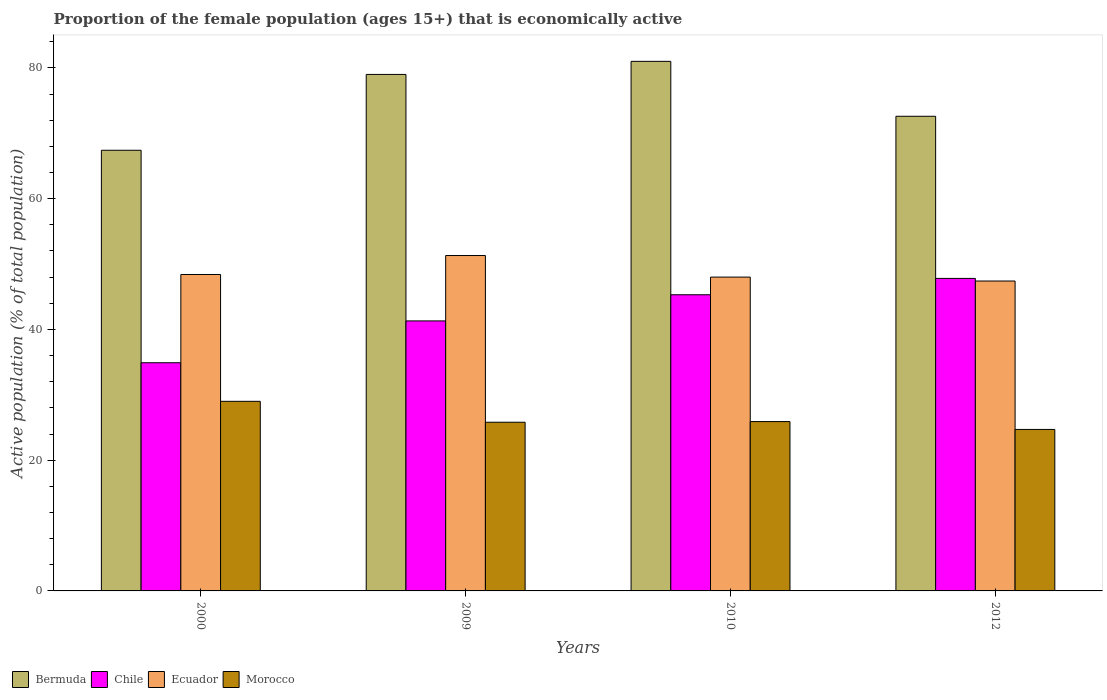How many groups of bars are there?
Offer a very short reply. 4. How many bars are there on the 3rd tick from the left?
Provide a short and direct response. 4. What is the label of the 1st group of bars from the left?
Offer a very short reply. 2000. In how many cases, is the number of bars for a given year not equal to the number of legend labels?
Make the answer very short. 0. What is the proportion of the female population that is economically active in Bermuda in 2009?
Your response must be concise. 79. Across all years, what is the maximum proportion of the female population that is economically active in Bermuda?
Ensure brevity in your answer.  81. Across all years, what is the minimum proportion of the female population that is economically active in Chile?
Offer a terse response. 34.9. In which year was the proportion of the female population that is economically active in Morocco maximum?
Ensure brevity in your answer.  2000. What is the total proportion of the female population that is economically active in Bermuda in the graph?
Keep it short and to the point. 300. What is the difference between the proportion of the female population that is economically active in Ecuador in 2009 and that in 2012?
Make the answer very short. 3.9. What is the difference between the proportion of the female population that is economically active in Chile in 2000 and the proportion of the female population that is economically active in Bermuda in 2012?
Your response must be concise. -37.7. What is the average proportion of the female population that is economically active in Morocco per year?
Your answer should be compact. 26.35. In the year 2000, what is the difference between the proportion of the female population that is economically active in Morocco and proportion of the female population that is economically active in Chile?
Your answer should be very brief. -5.9. What is the ratio of the proportion of the female population that is economically active in Morocco in 2010 to that in 2012?
Provide a succinct answer. 1.05. Is the difference between the proportion of the female population that is economically active in Morocco in 2010 and 2012 greater than the difference between the proportion of the female population that is economically active in Chile in 2010 and 2012?
Keep it short and to the point. Yes. What is the difference between the highest and the lowest proportion of the female population that is economically active in Bermuda?
Give a very brief answer. 13.6. In how many years, is the proportion of the female population that is economically active in Bermuda greater than the average proportion of the female population that is economically active in Bermuda taken over all years?
Keep it short and to the point. 2. Is the sum of the proportion of the female population that is economically active in Chile in 2000 and 2010 greater than the maximum proportion of the female population that is economically active in Bermuda across all years?
Offer a very short reply. No. Is it the case that in every year, the sum of the proportion of the female population that is economically active in Morocco and proportion of the female population that is economically active in Ecuador is greater than the sum of proportion of the female population that is economically active in Bermuda and proportion of the female population that is economically active in Chile?
Offer a very short reply. No. What does the 4th bar from the left in 2000 represents?
Give a very brief answer. Morocco. Is it the case that in every year, the sum of the proportion of the female population that is economically active in Ecuador and proportion of the female population that is economically active in Bermuda is greater than the proportion of the female population that is economically active in Morocco?
Offer a very short reply. Yes. Are all the bars in the graph horizontal?
Your response must be concise. No. How many years are there in the graph?
Provide a short and direct response. 4. Are the values on the major ticks of Y-axis written in scientific E-notation?
Your response must be concise. No. Where does the legend appear in the graph?
Provide a succinct answer. Bottom left. What is the title of the graph?
Give a very brief answer. Proportion of the female population (ages 15+) that is economically active. Does "Czech Republic" appear as one of the legend labels in the graph?
Your response must be concise. No. What is the label or title of the X-axis?
Make the answer very short. Years. What is the label or title of the Y-axis?
Your response must be concise. Active population (% of total population). What is the Active population (% of total population) in Bermuda in 2000?
Your answer should be compact. 67.4. What is the Active population (% of total population) of Chile in 2000?
Make the answer very short. 34.9. What is the Active population (% of total population) in Ecuador in 2000?
Provide a succinct answer. 48.4. What is the Active population (% of total population) of Bermuda in 2009?
Offer a terse response. 79. What is the Active population (% of total population) in Chile in 2009?
Keep it short and to the point. 41.3. What is the Active population (% of total population) of Ecuador in 2009?
Make the answer very short. 51.3. What is the Active population (% of total population) in Morocco in 2009?
Provide a succinct answer. 25.8. What is the Active population (% of total population) of Chile in 2010?
Ensure brevity in your answer.  45.3. What is the Active population (% of total population) of Morocco in 2010?
Give a very brief answer. 25.9. What is the Active population (% of total population) in Bermuda in 2012?
Provide a short and direct response. 72.6. What is the Active population (% of total population) in Chile in 2012?
Give a very brief answer. 47.8. What is the Active population (% of total population) in Ecuador in 2012?
Your answer should be very brief. 47.4. What is the Active population (% of total population) in Morocco in 2012?
Provide a short and direct response. 24.7. Across all years, what is the maximum Active population (% of total population) of Bermuda?
Keep it short and to the point. 81. Across all years, what is the maximum Active population (% of total population) of Chile?
Your answer should be very brief. 47.8. Across all years, what is the maximum Active population (% of total population) in Ecuador?
Your answer should be compact. 51.3. Across all years, what is the maximum Active population (% of total population) in Morocco?
Keep it short and to the point. 29. Across all years, what is the minimum Active population (% of total population) in Bermuda?
Ensure brevity in your answer.  67.4. Across all years, what is the minimum Active population (% of total population) of Chile?
Offer a very short reply. 34.9. Across all years, what is the minimum Active population (% of total population) of Ecuador?
Offer a very short reply. 47.4. Across all years, what is the minimum Active population (% of total population) of Morocco?
Your answer should be compact. 24.7. What is the total Active population (% of total population) of Bermuda in the graph?
Ensure brevity in your answer.  300. What is the total Active population (% of total population) of Chile in the graph?
Your response must be concise. 169.3. What is the total Active population (% of total population) of Ecuador in the graph?
Provide a succinct answer. 195.1. What is the total Active population (% of total population) in Morocco in the graph?
Give a very brief answer. 105.4. What is the difference between the Active population (% of total population) in Bermuda in 2000 and that in 2009?
Ensure brevity in your answer.  -11.6. What is the difference between the Active population (% of total population) of Chile in 2000 and that in 2009?
Ensure brevity in your answer.  -6.4. What is the difference between the Active population (% of total population) in Bermuda in 2000 and that in 2010?
Ensure brevity in your answer.  -13.6. What is the difference between the Active population (% of total population) in Chile in 2000 and that in 2010?
Give a very brief answer. -10.4. What is the difference between the Active population (% of total population) in Ecuador in 2000 and that in 2010?
Offer a terse response. 0.4. What is the difference between the Active population (% of total population) in Chile in 2000 and that in 2012?
Provide a short and direct response. -12.9. What is the difference between the Active population (% of total population) of Bermuda in 2009 and that in 2010?
Your answer should be compact. -2. What is the difference between the Active population (% of total population) in Chile in 2009 and that in 2010?
Make the answer very short. -4. What is the difference between the Active population (% of total population) in Ecuador in 2009 and that in 2010?
Provide a short and direct response. 3.3. What is the difference between the Active population (% of total population) of Bermuda in 2009 and that in 2012?
Provide a succinct answer. 6.4. What is the difference between the Active population (% of total population) of Chile in 2010 and that in 2012?
Your answer should be compact. -2.5. What is the difference between the Active population (% of total population) of Ecuador in 2010 and that in 2012?
Keep it short and to the point. 0.6. What is the difference between the Active population (% of total population) in Bermuda in 2000 and the Active population (% of total population) in Chile in 2009?
Ensure brevity in your answer.  26.1. What is the difference between the Active population (% of total population) in Bermuda in 2000 and the Active population (% of total population) in Ecuador in 2009?
Make the answer very short. 16.1. What is the difference between the Active population (% of total population) in Bermuda in 2000 and the Active population (% of total population) in Morocco in 2009?
Your response must be concise. 41.6. What is the difference between the Active population (% of total population) of Chile in 2000 and the Active population (% of total population) of Ecuador in 2009?
Provide a succinct answer. -16.4. What is the difference between the Active population (% of total population) of Ecuador in 2000 and the Active population (% of total population) of Morocco in 2009?
Make the answer very short. 22.6. What is the difference between the Active population (% of total population) of Bermuda in 2000 and the Active population (% of total population) of Chile in 2010?
Your answer should be compact. 22.1. What is the difference between the Active population (% of total population) in Bermuda in 2000 and the Active population (% of total population) in Ecuador in 2010?
Provide a short and direct response. 19.4. What is the difference between the Active population (% of total population) in Bermuda in 2000 and the Active population (% of total population) in Morocco in 2010?
Your answer should be compact. 41.5. What is the difference between the Active population (% of total population) in Chile in 2000 and the Active population (% of total population) in Ecuador in 2010?
Ensure brevity in your answer.  -13.1. What is the difference between the Active population (% of total population) of Ecuador in 2000 and the Active population (% of total population) of Morocco in 2010?
Make the answer very short. 22.5. What is the difference between the Active population (% of total population) in Bermuda in 2000 and the Active population (% of total population) in Chile in 2012?
Your answer should be very brief. 19.6. What is the difference between the Active population (% of total population) in Bermuda in 2000 and the Active population (% of total population) in Morocco in 2012?
Your response must be concise. 42.7. What is the difference between the Active population (% of total population) in Chile in 2000 and the Active population (% of total population) in Ecuador in 2012?
Keep it short and to the point. -12.5. What is the difference between the Active population (% of total population) in Ecuador in 2000 and the Active population (% of total population) in Morocco in 2012?
Provide a succinct answer. 23.7. What is the difference between the Active population (% of total population) in Bermuda in 2009 and the Active population (% of total population) in Chile in 2010?
Your response must be concise. 33.7. What is the difference between the Active population (% of total population) in Bermuda in 2009 and the Active population (% of total population) in Ecuador in 2010?
Keep it short and to the point. 31. What is the difference between the Active population (% of total population) in Bermuda in 2009 and the Active population (% of total population) in Morocco in 2010?
Your answer should be compact. 53.1. What is the difference between the Active population (% of total population) of Chile in 2009 and the Active population (% of total population) of Morocco in 2010?
Keep it short and to the point. 15.4. What is the difference between the Active population (% of total population) in Ecuador in 2009 and the Active population (% of total population) in Morocco in 2010?
Your answer should be very brief. 25.4. What is the difference between the Active population (% of total population) of Bermuda in 2009 and the Active population (% of total population) of Chile in 2012?
Offer a very short reply. 31.2. What is the difference between the Active population (% of total population) in Bermuda in 2009 and the Active population (% of total population) in Ecuador in 2012?
Ensure brevity in your answer.  31.6. What is the difference between the Active population (% of total population) of Bermuda in 2009 and the Active population (% of total population) of Morocco in 2012?
Offer a very short reply. 54.3. What is the difference between the Active population (% of total population) of Chile in 2009 and the Active population (% of total population) of Ecuador in 2012?
Ensure brevity in your answer.  -6.1. What is the difference between the Active population (% of total population) in Ecuador in 2009 and the Active population (% of total population) in Morocco in 2012?
Your response must be concise. 26.6. What is the difference between the Active population (% of total population) in Bermuda in 2010 and the Active population (% of total population) in Chile in 2012?
Keep it short and to the point. 33.2. What is the difference between the Active population (% of total population) in Bermuda in 2010 and the Active population (% of total population) in Ecuador in 2012?
Provide a short and direct response. 33.6. What is the difference between the Active population (% of total population) in Bermuda in 2010 and the Active population (% of total population) in Morocco in 2012?
Offer a terse response. 56.3. What is the difference between the Active population (% of total population) in Chile in 2010 and the Active population (% of total population) in Ecuador in 2012?
Offer a very short reply. -2.1. What is the difference between the Active population (% of total population) of Chile in 2010 and the Active population (% of total population) of Morocco in 2012?
Provide a succinct answer. 20.6. What is the difference between the Active population (% of total population) in Ecuador in 2010 and the Active population (% of total population) in Morocco in 2012?
Offer a very short reply. 23.3. What is the average Active population (% of total population) of Chile per year?
Offer a terse response. 42.33. What is the average Active population (% of total population) of Ecuador per year?
Your answer should be compact. 48.77. What is the average Active population (% of total population) of Morocco per year?
Your response must be concise. 26.35. In the year 2000, what is the difference between the Active population (% of total population) in Bermuda and Active population (% of total population) in Chile?
Your answer should be compact. 32.5. In the year 2000, what is the difference between the Active population (% of total population) of Bermuda and Active population (% of total population) of Ecuador?
Provide a short and direct response. 19. In the year 2000, what is the difference between the Active population (% of total population) of Bermuda and Active population (% of total population) of Morocco?
Offer a terse response. 38.4. In the year 2000, what is the difference between the Active population (% of total population) of Chile and Active population (% of total population) of Morocco?
Offer a terse response. 5.9. In the year 2009, what is the difference between the Active population (% of total population) of Bermuda and Active population (% of total population) of Chile?
Give a very brief answer. 37.7. In the year 2009, what is the difference between the Active population (% of total population) of Bermuda and Active population (% of total population) of Ecuador?
Provide a succinct answer. 27.7. In the year 2009, what is the difference between the Active population (% of total population) of Bermuda and Active population (% of total population) of Morocco?
Keep it short and to the point. 53.2. In the year 2009, what is the difference between the Active population (% of total population) of Chile and Active population (% of total population) of Ecuador?
Your answer should be very brief. -10. In the year 2009, what is the difference between the Active population (% of total population) of Chile and Active population (% of total population) of Morocco?
Your response must be concise. 15.5. In the year 2009, what is the difference between the Active population (% of total population) in Ecuador and Active population (% of total population) in Morocco?
Your response must be concise. 25.5. In the year 2010, what is the difference between the Active population (% of total population) in Bermuda and Active population (% of total population) in Chile?
Your response must be concise. 35.7. In the year 2010, what is the difference between the Active population (% of total population) of Bermuda and Active population (% of total population) of Morocco?
Your answer should be compact. 55.1. In the year 2010, what is the difference between the Active population (% of total population) of Chile and Active population (% of total population) of Morocco?
Your answer should be very brief. 19.4. In the year 2010, what is the difference between the Active population (% of total population) in Ecuador and Active population (% of total population) in Morocco?
Give a very brief answer. 22.1. In the year 2012, what is the difference between the Active population (% of total population) of Bermuda and Active population (% of total population) of Chile?
Your answer should be very brief. 24.8. In the year 2012, what is the difference between the Active population (% of total population) in Bermuda and Active population (% of total population) in Ecuador?
Offer a terse response. 25.2. In the year 2012, what is the difference between the Active population (% of total population) of Bermuda and Active population (% of total population) of Morocco?
Ensure brevity in your answer.  47.9. In the year 2012, what is the difference between the Active population (% of total population) in Chile and Active population (% of total population) in Ecuador?
Provide a short and direct response. 0.4. In the year 2012, what is the difference between the Active population (% of total population) of Chile and Active population (% of total population) of Morocco?
Provide a succinct answer. 23.1. In the year 2012, what is the difference between the Active population (% of total population) in Ecuador and Active population (% of total population) in Morocco?
Give a very brief answer. 22.7. What is the ratio of the Active population (% of total population) in Bermuda in 2000 to that in 2009?
Your answer should be very brief. 0.85. What is the ratio of the Active population (% of total population) of Chile in 2000 to that in 2009?
Ensure brevity in your answer.  0.84. What is the ratio of the Active population (% of total population) of Ecuador in 2000 to that in 2009?
Keep it short and to the point. 0.94. What is the ratio of the Active population (% of total population) in Morocco in 2000 to that in 2009?
Your response must be concise. 1.12. What is the ratio of the Active population (% of total population) in Bermuda in 2000 to that in 2010?
Your answer should be compact. 0.83. What is the ratio of the Active population (% of total population) of Chile in 2000 to that in 2010?
Make the answer very short. 0.77. What is the ratio of the Active population (% of total population) of Ecuador in 2000 to that in 2010?
Provide a succinct answer. 1.01. What is the ratio of the Active population (% of total population) in Morocco in 2000 to that in 2010?
Your answer should be very brief. 1.12. What is the ratio of the Active population (% of total population) in Bermuda in 2000 to that in 2012?
Provide a short and direct response. 0.93. What is the ratio of the Active population (% of total population) of Chile in 2000 to that in 2012?
Keep it short and to the point. 0.73. What is the ratio of the Active population (% of total population) of Ecuador in 2000 to that in 2012?
Ensure brevity in your answer.  1.02. What is the ratio of the Active population (% of total population) in Morocco in 2000 to that in 2012?
Make the answer very short. 1.17. What is the ratio of the Active population (% of total population) in Bermuda in 2009 to that in 2010?
Make the answer very short. 0.98. What is the ratio of the Active population (% of total population) in Chile in 2009 to that in 2010?
Offer a terse response. 0.91. What is the ratio of the Active population (% of total population) of Ecuador in 2009 to that in 2010?
Provide a short and direct response. 1.07. What is the ratio of the Active population (% of total population) in Morocco in 2009 to that in 2010?
Your answer should be very brief. 1. What is the ratio of the Active population (% of total population) in Bermuda in 2009 to that in 2012?
Your response must be concise. 1.09. What is the ratio of the Active population (% of total population) in Chile in 2009 to that in 2012?
Your answer should be compact. 0.86. What is the ratio of the Active population (% of total population) of Ecuador in 2009 to that in 2012?
Provide a succinct answer. 1.08. What is the ratio of the Active population (% of total population) of Morocco in 2009 to that in 2012?
Offer a very short reply. 1.04. What is the ratio of the Active population (% of total population) in Bermuda in 2010 to that in 2012?
Ensure brevity in your answer.  1.12. What is the ratio of the Active population (% of total population) of Chile in 2010 to that in 2012?
Offer a terse response. 0.95. What is the ratio of the Active population (% of total population) in Ecuador in 2010 to that in 2012?
Your answer should be very brief. 1.01. What is the ratio of the Active population (% of total population) in Morocco in 2010 to that in 2012?
Give a very brief answer. 1.05. What is the difference between the highest and the lowest Active population (% of total population) in Bermuda?
Provide a succinct answer. 13.6. 